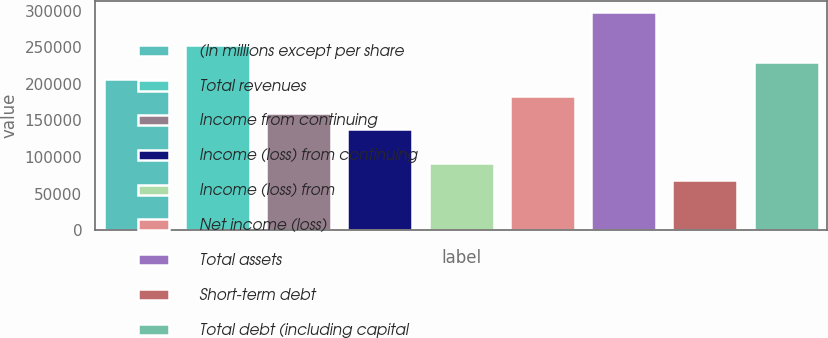Convert chart to OTSL. <chart><loc_0><loc_0><loc_500><loc_500><bar_chart><fcel>(In millions except per share<fcel>Total revenues<fcel>Income from continuing<fcel>Income (loss) from continuing<fcel>Income (loss) from<fcel>Net income (loss)<fcel>Total assets<fcel>Short-term debt<fcel>Total debt (including capital<nl><fcel>206654<fcel>252578<fcel>160731<fcel>137770<fcel>91846.9<fcel>183693<fcel>298501<fcel>68885.3<fcel>229616<nl></chart> 